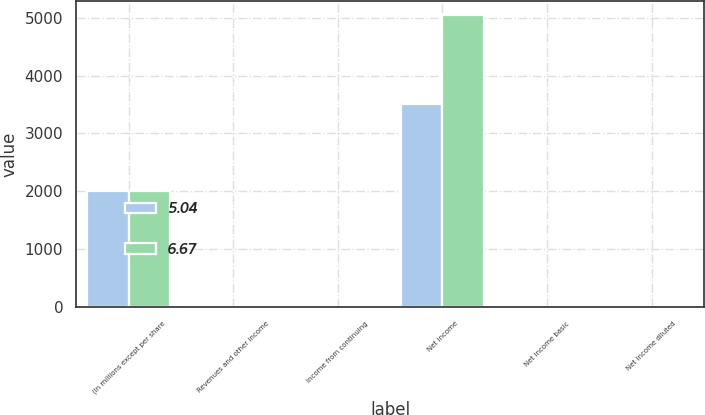<chart> <loc_0><loc_0><loc_500><loc_500><stacked_bar_chart><ecel><fcel>(In millions except per share<fcel>Revenues and other income<fcel>Income from continuing<fcel>Net income<fcel>Net income basic<fcel>Net income diluted<nl><fcel>5.04<fcel>2007<fcel>6.695<fcel>5.03<fcel>3503<fcel>5.08<fcel>5.04<nl><fcel>6.67<fcel>2006<fcel>6.695<fcel>6.3<fcel>5042<fcel>6.72<fcel>6.67<nl></chart> 